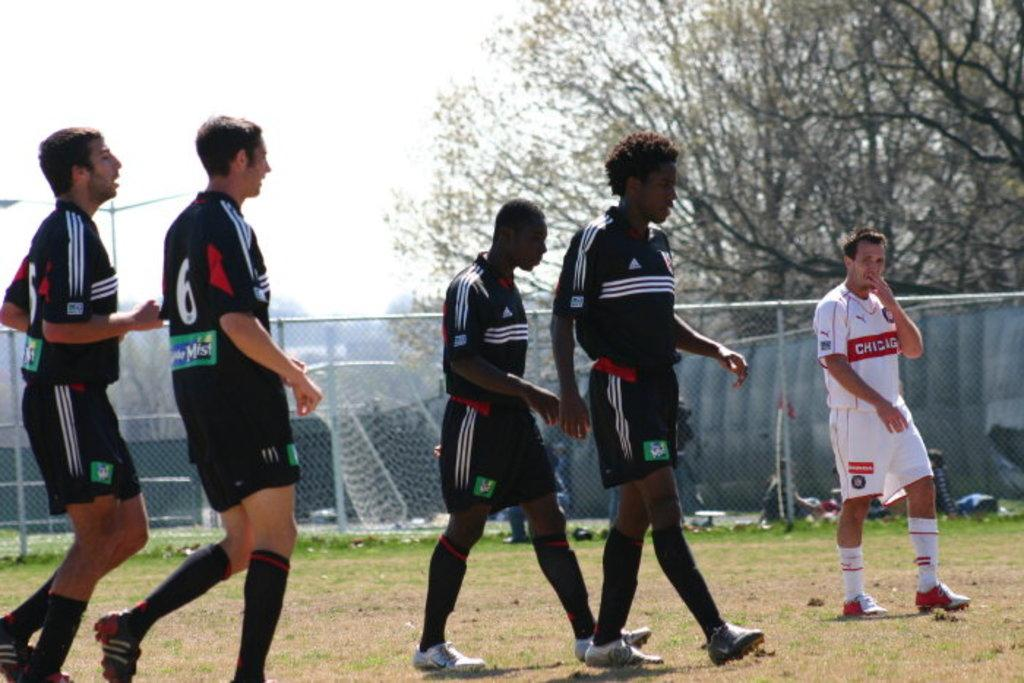<image>
Share a concise interpretation of the image provided. Soccer players wearing Adidas and the Goalie wearing a Chigig jersey. 